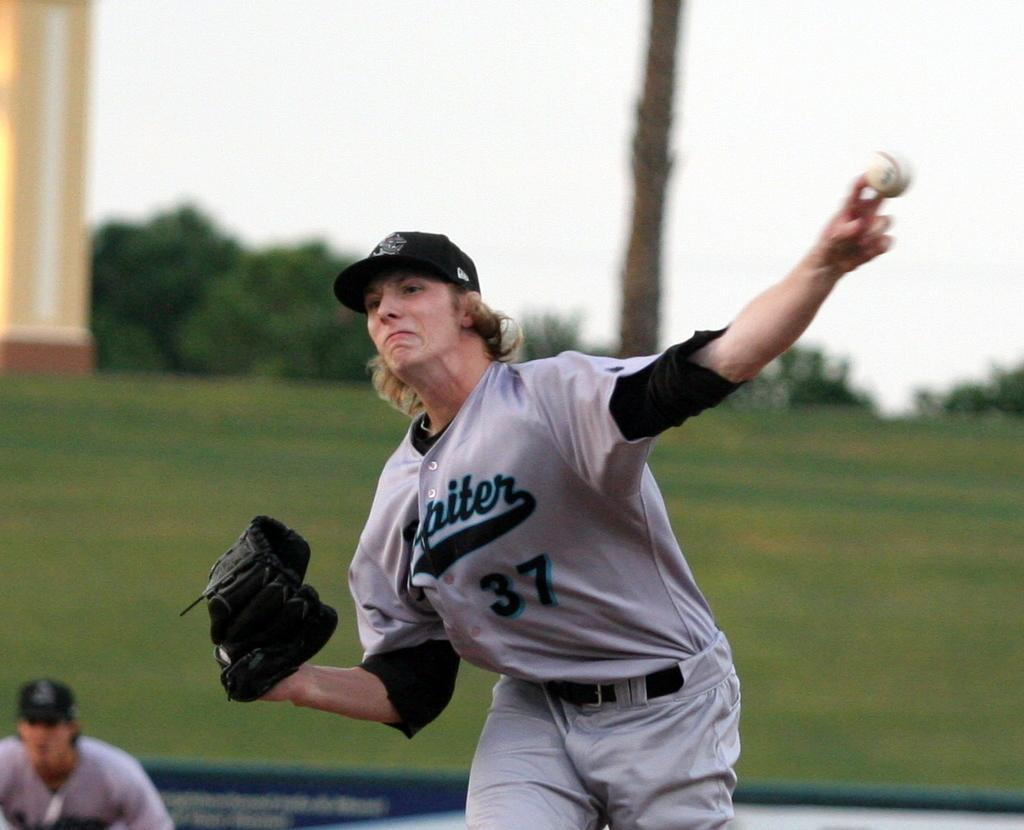<image>
Describe the image concisely. Baseball player wearing number 37 pitching the ball. 